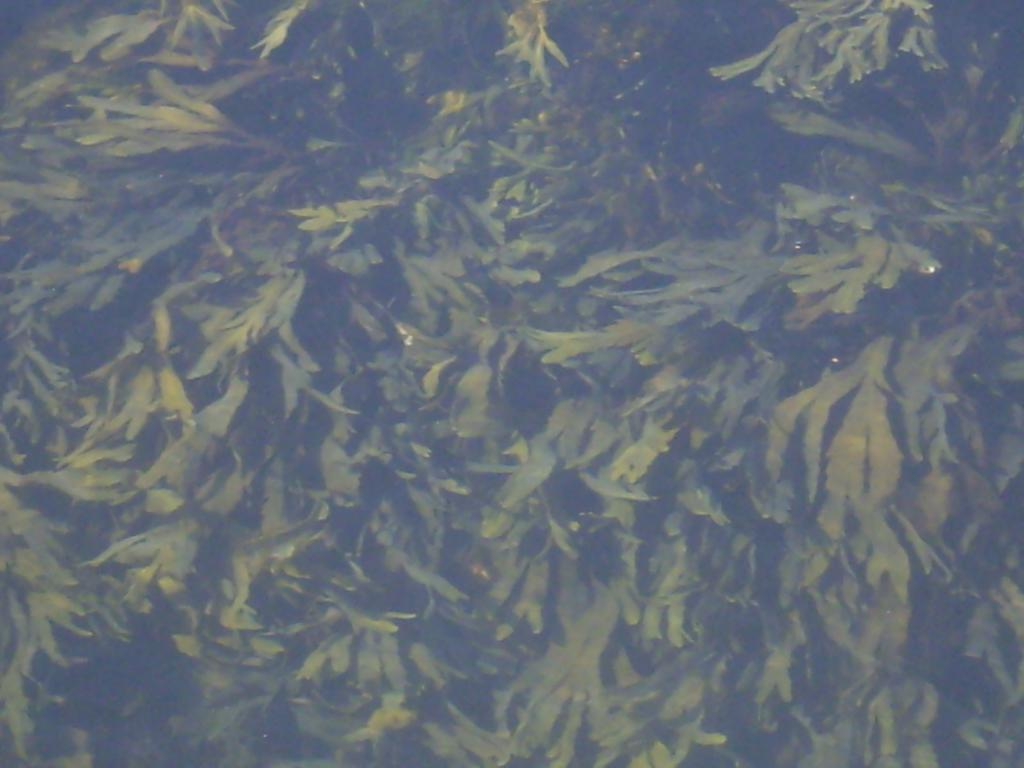Where was the image taken? The image was taken outdoors. What type of vegetation can be seen in the image? There are trees with green leaves in the image. Can you tell me how many horses are visible in the image? There are no horses present in the image. What type of ground is visible in the image? The provided facts do not mention the ground, so it cannot be determined from the image. 